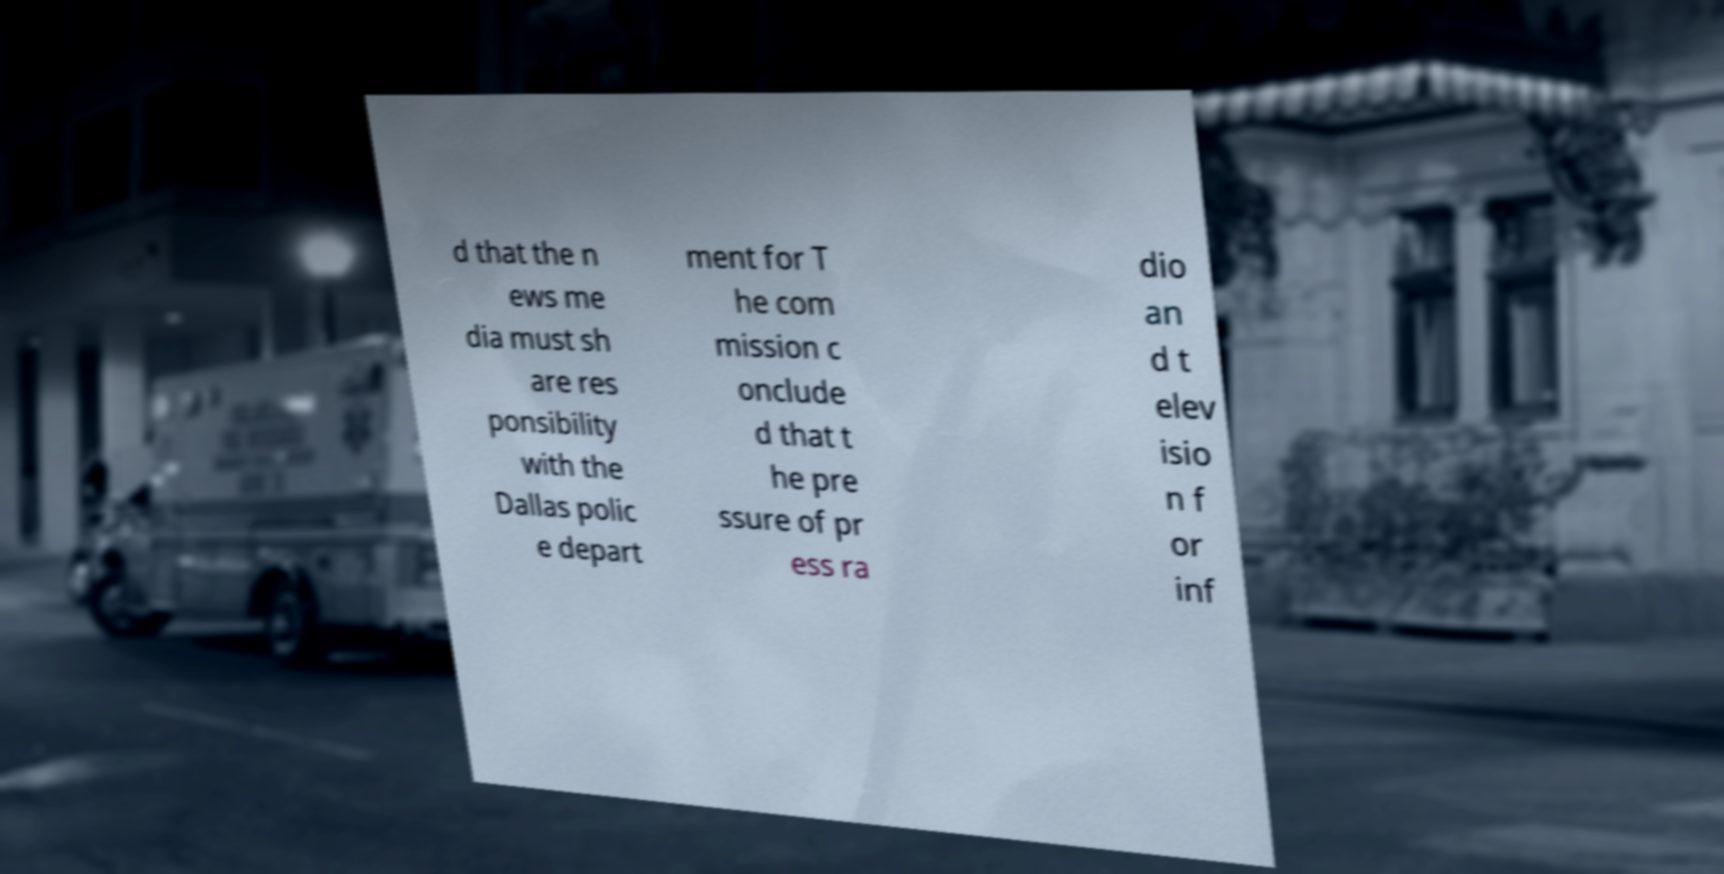I need the written content from this picture converted into text. Can you do that? d that the n ews me dia must sh are res ponsibility with the Dallas polic e depart ment for T he com mission c onclude d that t he pre ssure of pr ess ra dio an d t elev isio n f or inf 